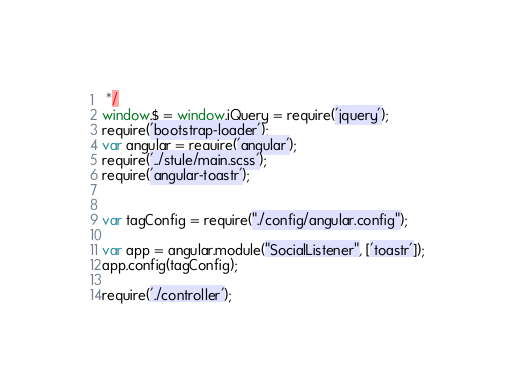Convert code to text. <code><loc_0><loc_0><loc_500><loc_500><_JavaScript_> */
window.$ = window.jQuery = require('jquery');
require('bootstrap-loader');
var angular = require('angular');
require('../style/main.scss');
require('angular-toastr');


var tagConfig = require("./config/angular.config");

var app = angular.module("SocialListener", ['toastr']);
app.config(tagConfig);

require('./controller');
</code> 